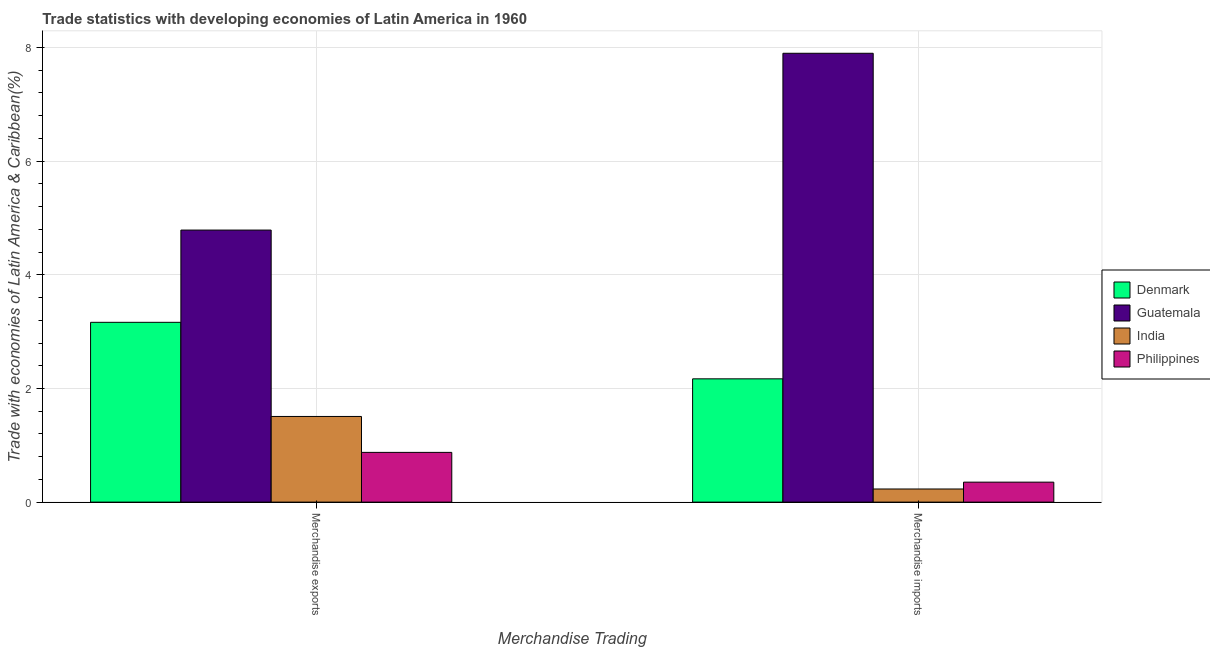How many groups of bars are there?
Provide a short and direct response. 2. Are the number of bars per tick equal to the number of legend labels?
Make the answer very short. Yes. How many bars are there on the 1st tick from the left?
Make the answer very short. 4. What is the merchandise imports in Philippines?
Your answer should be compact. 0.35. Across all countries, what is the maximum merchandise imports?
Make the answer very short. 7.9. Across all countries, what is the minimum merchandise imports?
Offer a terse response. 0.23. In which country was the merchandise imports maximum?
Your answer should be very brief. Guatemala. In which country was the merchandise imports minimum?
Provide a succinct answer. India. What is the total merchandise exports in the graph?
Keep it short and to the point. 10.33. What is the difference between the merchandise exports in Denmark and that in India?
Make the answer very short. 1.66. What is the difference between the merchandise imports in India and the merchandise exports in Denmark?
Offer a very short reply. -2.93. What is the average merchandise exports per country?
Provide a short and direct response. 2.58. What is the difference between the merchandise exports and merchandise imports in India?
Provide a short and direct response. 1.28. In how many countries, is the merchandise exports greater than 4 %?
Provide a short and direct response. 1. What is the ratio of the merchandise exports in Denmark to that in India?
Your answer should be compact. 2.1. Is the merchandise exports in Guatemala less than that in India?
Provide a succinct answer. No. What does the 4th bar from the right in Merchandise imports represents?
Give a very brief answer. Denmark. How many bars are there?
Provide a succinct answer. 8. How many countries are there in the graph?
Ensure brevity in your answer.  4. What is the difference between two consecutive major ticks on the Y-axis?
Ensure brevity in your answer.  2. Does the graph contain any zero values?
Your answer should be very brief. No. Does the graph contain grids?
Your answer should be very brief. Yes. Where does the legend appear in the graph?
Keep it short and to the point. Center right. How are the legend labels stacked?
Ensure brevity in your answer.  Vertical. What is the title of the graph?
Provide a short and direct response. Trade statistics with developing economies of Latin America in 1960. What is the label or title of the X-axis?
Ensure brevity in your answer.  Merchandise Trading. What is the label or title of the Y-axis?
Keep it short and to the point. Trade with economies of Latin America & Caribbean(%). What is the Trade with economies of Latin America & Caribbean(%) in Denmark in Merchandise exports?
Your response must be concise. 3.16. What is the Trade with economies of Latin America & Caribbean(%) of Guatemala in Merchandise exports?
Provide a short and direct response. 4.79. What is the Trade with economies of Latin America & Caribbean(%) in India in Merchandise exports?
Give a very brief answer. 1.51. What is the Trade with economies of Latin America & Caribbean(%) in Philippines in Merchandise exports?
Offer a very short reply. 0.88. What is the Trade with economies of Latin America & Caribbean(%) of Denmark in Merchandise imports?
Offer a terse response. 2.17. What is the Trade with economies of Latin America & Caribbean(%) of Guatemala in Merchandise imports?
Offer a very short reply. 7.9. What is the Trade with economies of Latin America & Caribbean(%) in India in Merchandise imports?
Provide a succinct answer. 0.23. What is the Trade with economies of Latin America & Caribbean(%) of Philippines in Merchandise imports?
Your response must be concise. 0.35. Across all Merchandise Trading, what is the maximum Trade with economies of Latin America & Caribbean(%) of Denmark?
Your answer should be very brief. 3.16. Across all Merchandise Trading, what is the maximum Trade with economies of Latin America & Caribbean(%) in Guatemala?
Offer a very short reply. 7.9. Across all Merchandise Trading, what is the maximum Trade with economies of Latin America & Caribbean(%) in India?
Offer a very short reply. 1.51. Across all Merchandise Trading, what is the maximum Trade with economies of Latin America & Caribbean(%) of Philippines?
Your answer should be compact. 0.88. Across all Merchandise Trading, what is the minimum Trade with economies of Latin America & Caribbean(%) in Denmark?
Your answer should be compact. 2.17. Across all Merchandise Trading, what is the minimum Trade with economies of Latin America & Caribbean(%) of Guatemala?
Your response must be concise. 4.79. Across all Merchandise Trading, what is the minimum Trade with economies of Latin America & Caribbean(%) of India?
Provide a short and direct response. 0.23. Across all Merchandise Trading, what is the minimum Trade with economies of Latin America & Caribbean(%) of Philippines?
Provide a short and direct response. 0.35. What is the total Trade with economies of Latin America & Caribbean(%) in Denmark in the graph?
Your answer should be compact. 5.33. What is the total Trade with economies of Latin America & Caribbean(%) in Guatemala in the graph?
Ensure brevity in your answer.  12.69. What is the total Trade with economies of Latin America & Caribbean(%) of India in the graph?
Give a very brief answer. 1.74. What is the total Trade with economies of Latin America & Caribbean(%) of Philippines in the graph?
Provide a succinct answer. 1.23. What is the difference between the Trade with economies of Latin America & Caribbean(%) in Denmark in Merchandise exports and that in Merchandise imports?
Provide a short and direct response. 0.99. What is the difference between the Trade with economies of Latin America & Caribbean(%) of Guatemala in Merchandise exports and that in Merchandise imports?
Your answer should be very brief. -3.11. What is the difference between the Trade with economies of Latin America & Caribbean(%) of India in Merchandise exports and that in Merchandise imports?
Keep it short and to the point. 1.28. What is the difference between the Trade with economies of Latin America & Caribbean(%) of Philippines in Merchandise exports and that in Merchandise imports?
Ensure brevity in your answer.  0.52. What is the difference between the Trade with economies of Latin America & Caribbean(%) in Denmark in Merchandise exports and the Trade with economies of Latin America & Caribbean(%) in Guatemala in Merchandise imports?
Your answer should be compact. -4.73. What is the difference between the Trade with economies of Latin America & Caribbean(%) of Denmark in Merchandise exports and the Trade with economies of Latin America & Caribbean(%) of India in Merchandise imports?
Your response must be concise. 2.93. What is the difference between the Trade with economies of Latin America & Caribbean(%) in Denmark in Merchandise exports and the Trade with economies of Latin America & Caribbean(%) in Philippines in Merchandise imports?
Provide a succinct answer. 2.81. What is the difference between the Trade with economies of Latin America & Caribbean(%) in Guatemala in Merchandise exports and the Trade with economies of Latin America & Caribbean(%) in India in Merchandise imports?
Your answer should be compact. 4.56. What is the difference between the Trade with economies of Latin America & Caribbean(%) in Guatemala in Merchandise exports and the Trade with economies of Latin America & Caribbean(%) in Philippines in Merchandise imports?
Provide a short and direct response. 4.44. What is the difference between the Trade with economies of Latin America & Caribbean(%) of India in Merchandise exports and the Trade with economies of Latin America & Caribbean(%) of Philippines in Merchandise imports?
Make the answer very short. 1.16. What is the average Trade with economies of Latin America & Caribbean(%) in Denmark per Merchandise Trading?
Ensure brevity in your answer.  2.67. What is the average Trade with economies of Latin America & Caribbean(%) in Guatemala per Merchandise Trading?
Offer a very short reply. 6.34. What is the average Trade with economies of Latin America & Caribbean(%) in India per Merchandise Trading?
Your answer should be compact. 0.87. What is the average Trade with economies of Latin America & Caribbean(%) in Philippines per Merchandise Trading?
Give a very brief answer. 0.61. What is the difference between the Trade with economies of Latin America & Caribbean(%) of Denmark and Trade with economies of Latin America & Caribbean(%) of Guatemala in Merchandise exports?
Keep it short and to the point. -1.62. What is the difference between the Trade with economies of Latin America & Caribbean(%) in Denmark and Trade with economies of Latin America & Caribbean(%) in India in Merchandise exports?
Your answer should be compact. 1.66. What is the difference between the Trade with economies of Latin America & Caribbean(%) in Denmark and Trade with economies of Latin America & Caribbean(%) in Philippines in Merchandise exports?
Offer a very short reply. 2.29. What is the difference between the Trade with economies of Latin America & Caribbean(%) of Guatemala and Trade with economies of Latin America & Caribbean(%) of India in Merchandise exports?
Provide a short and direct response. 3.28. What is the difference between the Trade with economies of Latin America & Caribbean(%) in Guatemala and Trade with economies of Latin America & Caribbean(%) in Philippines in Merchandise exports?
Offer a terse response. 3.91. What is the difference between the Trade with economies of Latin America & Caribbean(%) of India and Trade with economies of Latin America & Caribbean(%) of Philippines in Merchandise exports?
Ensure brevity in your answer.  0.63. What is the difference between the Trade with economies of Latin America & Caribbean(%) in Denmark and Trade with economies of Latin America & Caribbean(%) in Guatemala in Merchandise imports?
Give a very brief answer. -5.73. What is the difference between the Trade with economies of Latin America & Caribbean(%) in Denmark and Trade with economies of Latin America & Caribbean(%) in India in Merchandise imports?
Offer a terse response. 1.94. What is the difference between the Trade with economies of Latin America & Caribbean(%) in Denmark and Trade with economies of Latin America & Caribbean(%) in Philippines in Merchandise imports?
Your response must be concise. 1.82. What is the difference between the Trade with economies of Latin America & Caribbean(%) of Guatemala and Trade with economies of Latin America & Caribbean(%) of India in Merchandise imports?
Your answer should be compact. 7.67. What is the difference between the Trade with economies of Latin America & Caribbean(%) of Guatemala and Trade with economies of Latin America & Caribbean(%) of Philippines in Merchandise imports?
Offer a terse response. 7.55. What is the difference between the Trade with economies of Latin America & Caribbean(%) in India and Trade with economies of Latin America & Caribbean(%) in Philippines in Merchandise imports?
Your answer should be very brief. -0.12. What is the ratio of the Trade with economies of Latin America & Caribbean(%) in Denmark in Merchandise exports to that in Merchandise imports?
Give a very brief answer. 1.46. What is the ratio of the Trade with economies of Latin America & Caribbean(%) in Guatemala in Merchandise exports to that in Merchandise imports?
Provide a succinct answer. 0.61. What is the ratio of the Trade with economies of Latin America & Caribbean(%) in India in Merchandise exports to that in Merchandise imports?
Your answer should be very brief. 6.52. What is the ratio of the Trade with economies of Latin America & Caribbean(%) of Philippines in Merchandise exports to that in Merchandise imports?
Ensure brevity in your answer.  2.49. What is the difference between the highest and the second highest Trade with economies of Latin America & Caribbean(%) of Denmark?
Offer a terse response. 0.99. What is the difference between the highest and the second highest Trade with economies of Latin America & Caribbean(%) in Guatemala?
Your answer should be compact. 3.11. What is the difference between the highest and the second highest Trade with economies of Latin America & Caribbean(%) in India?
Your answer should be compact. 1.28. What is the difference between the highest and the second highest Trade with economies of Latin America & Caribbean(%) in Philippines?
Offer a terse response. 0.52. What is the difference between the highest and the lowest Trade with economies of Latin America & Caribbean(%) in Denmark?
Give a very brief answer. 0.99. What is the difference between the highest and the lowest Trade with economies of Latin America & Caribbean(%) in Guatemala?
Offer a very short reply. 3.11. What is the difference between the highest and the lowest Trade with economies of Latin America & Caribbean(%) of India?
Offer a very short reply. 1.28. What is the difference between the highest and the lowest Trade with economies of Latin America & Caribbean(%) of Philippines?
Keep it short and to the point. 0.52. 